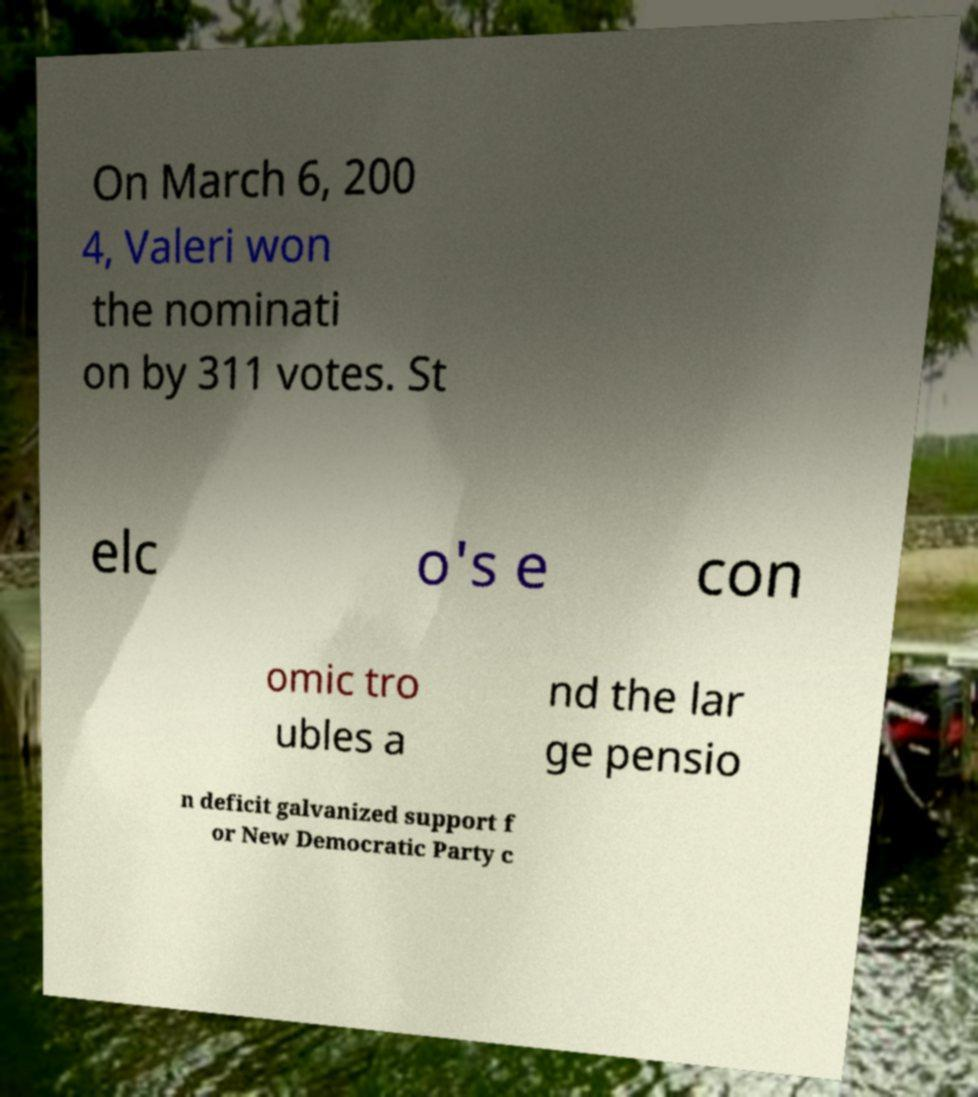For documentation purposes, I need the text within this image transcribed. Could you provide that? On March 6, 200 4, Valeri won the nominati on by 311 votes. St elc o's e con omic tro ubles a nd the lar ge pensio n deficit galvanized support f or New Democratic Party c 